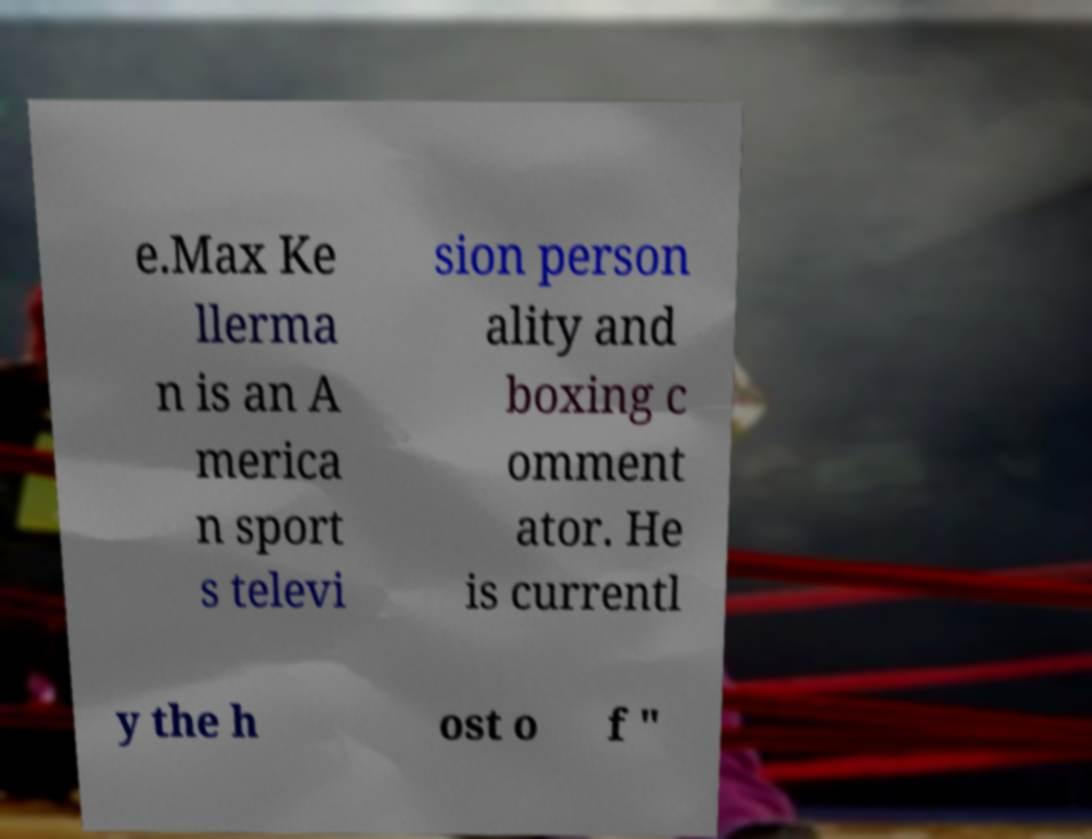Could you extract and type out the text from this image? e.Max Ke llerma n is an A merica n sport s televi sion person ality and boxing c omment ator. He is currentl y the h ost o f " 